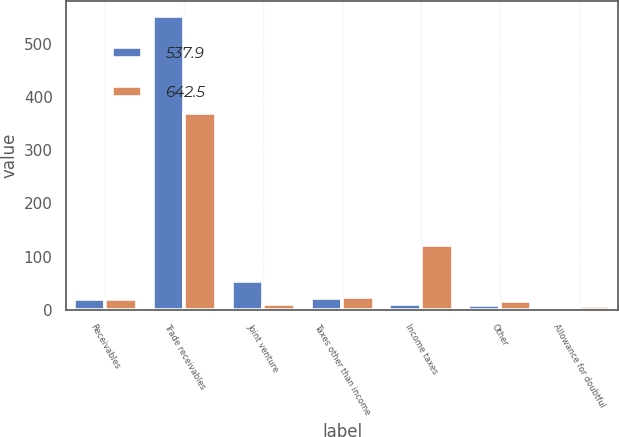<chart> <loc_0><loc_0><loc_500><loc_500><stacked_bar_chart><ecel><fcel>Receivables<fcel>Trade receivables<fcel>Joint venture<fcel>Taxes other than income<fcel>Income taxes<fcel>Other<fcel>Allowance for doubtful<nl><fcel>537.9<fcel>19.3<fcel>552.5<fcel>53.1<fcel>21.8<fcel>11.3<fcel>8.6<fcel>4.8<nl><fcel>642.5<fcel>19.3<fcel>370.7<fcel>10.5<fcel>23.9<fcel>122.2<fcel>16.8<fcel>6.2<nl></chart> 